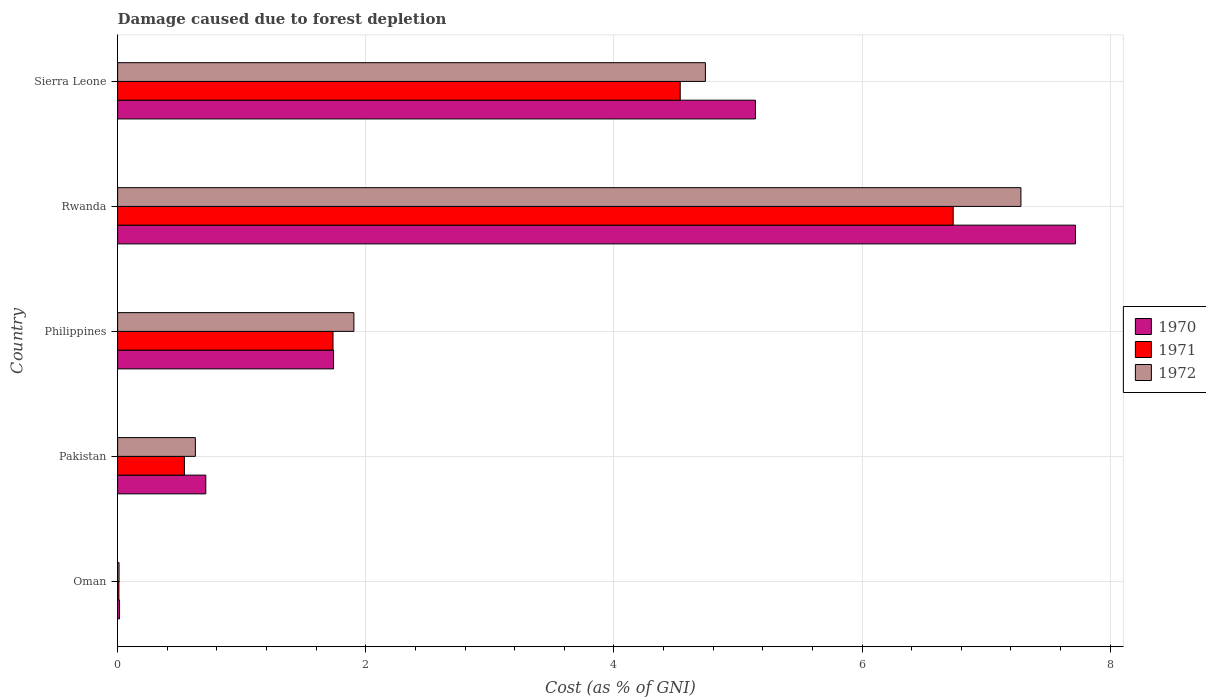How many different coloured bars are there?
Your response must be concise. 3. How many groups of bars are there?
Ensure brevity in your answer.  5. Are the number of bars per tick equal to the number of legend labels?
Offer a very short reply. Yes. What is the label of the 2nd group of bars from the top?
Ensure brevity in your answer.  Rwanda. In how many cases, is the number of bars for a given country not equal to the number of legend labels?
Make the answer very short. 0. What is the cost of damage caused due to forest depletion in 1972 in Rwanda?
Ensure brevity in your answer.  7.28. Across all countries, what is the maximum cost of damage caused due to forest depletion in 1970?
Your answer should be compact. 7.72. Across all countries, what is the minimum cost of damage caused due to forest depletion in 1972?
Give a very brief answer. 0.01. In which country was the cost of damage caused due to forest depletion in 1970 maximum?
Keep it short and to the point. Rwanda. In which country was the cost of damage caused due to forest depletion in 1972 minimum?
Provide a succinct answer. Oman. What is the total cost of damage caused due to forest depletion in 1972 in the graph?
Offer a terse response. 14.56. What is the difference between the cost of damage caused due to forest depletion in 1972 in Oman and that in Pakistan?
Offer a very short reply. -0.62. What is the difference between the cost of damage caused due to forest depletion in 1970 in Philippines and the cost of damage caused due to forest depletion in 1972 in Oman?
Provide a succinct answer. 1.73. What is the average cost of damage caused due to forest depletion in 1970 per country?
Your response must be concise. 3.07. What is the difference between the cost of damage caused due to forest depletion in 1972 and cost of damage caused due to forest depletion in 1971 in Sierra Leone?
Provide a succinct answer. 0.2. What is the ratio of the cost of damage caused due to forest depletion in 1971 in Pakistan to that in Philippines?
Ensure brevity in your answer.  0.31. Is the difference between the cost of damage caused due to forest depletion in 1972 in Pakistan and Sierra Leone greater than the difference between the cost of damage caused due to forest depletion in 1971 in Pakistan and Sierra Leone?
Provide a short and direct response. No. What is the difference between the highest and the second highest cost of damage caused due to forest depletion in 1970?
Make the answer very short. 2.58. What is the difference between the highest and the lowest cost of damage caused due to forest depletion in 1971?
Provide a short and direct response. 6.72. In how many countries, is the cost of damage caused due to forest depletion in 1970 greater than the average cost of damage caused due to forest depletion in 1970 taken over all countries?
Your answer should be compact. 2. What does the 1st bar from the top in Philippines represents?
Keep it short and to the point. 1972. What does the 1st bar from the bottom in Rwanda represents?
Your answer should be compact. 1970. Are all the bars in the graph horizontal?
Your response must be concise. Yes. What is the difference between two consecutive major ticks on the X-axis?
Keep it short and to the point. 2. Does the graph contain any zero values?
Your response must be concise. No. How many legend labels are there?
Give a very brief answer. 3. How are the legend labels stacked?
Your response must be concise. Vertical. What is the title of the graph?
Provide a short and direct response. Damage caused due to forest depletion. What is the label or title of the X-axis?
Offer a terse response. Cost (as % of GNI). What is the Cost (as % of GNI) of 1970 in Oman?
Your answer should be very brief. 0.02. What is the Cost (as % of GNI) in 1971 in Oman?
Provide a succinct answer. 0.01. What is the Cost (as % of GNI) of 1972 in Oman?
Make the answer very short. 0.01. What is the Cost (as % of GNI) of 1970 in Pakistan?
Make the answer very short. 0.71. What is the Cost (as % of GNI) of 1971 in Pakistan?
Offer a terse response. 0.54. What is the Cost (as % of GNI) of 1972 in Pakistan?
Give a very brief answer. 0.63. What is the Cost (as % of GNI) of 1970 in Philippines?
Ensure brevity in your answer.  1.74. What is the Cost (as % of GNI) in 1971 in Philippines?
Offer a very short reply. 1.74. What is the Cost (as % of GNI) of 1972 in Philippines?
Your response must be concise. 1.9. What is the Cost (as % of GNI) in 1970 in Rwanda?
Your answer should be very brief. 7.72. What is the Cost (as % of GNI) of 1971 in Rwanda?
Give a very brief answer. 6.73. What is the Cost (as % of GNI) of 1972 in Rwanda?
Your answer should be compact. 7.28. What is the Cost (as % of GNI) of 1970 in Sierra Leone?
Offer a terse response. 5.14. What is the Cost (as % of GNI) in 1971 in Sierra Leone?
Keep it short and to the point. 4.53. What is the Cost (as % of GNI) in 1972 in Sierra Leone?
Offer a very short reply. 4.74. Across all countries, what is the maximum Cost (as % of GNI) of 1970?
Give a very brief answer. 7.72. Across all countries, what is the maximum Cost (as % of GNI) of 1971?
Ensure brevity in your answer.  6.73. Across all countries, what is the maximum Cost (as % of GNI) in 1972?
Your response must be concise. 7.28. Across all countries, what is the minimum Cost (as % of GNI) in 1970?
Your answer should be very brief. 0.02. Across all countries, what is the minimum Cost (as % of GNI) in 1971?
Your answer should be very brief. 0.01. Across all countries, what is the minimum Cost (as % of GNI) of 1972?
Make the answer very short. 0.01. What is the total Cost (as % of GNI) of 1970 in the graph?
Ensure brevity in your answer.  15.33. What is the total Cost (as % of GNI) in 1971 in the graph?
Your answer should be very brief. 13.55. What is the total Cost (as % of GNI) in 1972 in the graph?
Provide a succinct answer. 14.56. What is the difference between the Cost (as % of GNI) of 1970 in Oman and that in Pakistan?
Ensure brevity in your answer.  -0.7. What is the difference between the Cost (as % of GNI) in 1971 in Oman and that in Pakistan?
Your answer should be compact. -0.53. What is the difference between the Cost (as % of GNI) of 1972 in Oman and that in Pakistan?
Your answer should be compact. -0.62. What is the difference between the Cost (as % of GNI) of 1970 in Oman and that in Philippines?
Provide a succinct answer. -1.72. What is the difference between the Cost (as % of GNI) in 1971 in Oman and that in Philippines?
Offer a very short reply. -1.73. What is the difference between the Cost (as % of GNI) of 1972 in Oman and that in Philippines?
Make the answer very short. -1.89. What is the difference between the Cost (as % of GNI) in 1970 in Oman and that in Rwanda?
Make the answer very short. -7.7. What is the difference between the Cost (as % of GNI) of 1971 in Oman and that in Rwanda?
Give a very brief answer. -6.72. What is the difference between the Cost (as % of GNI) in 1972 in Oman and that in Rwanda?
Make the answer very short. -7.27. What is the difference between the Cost (as % of GNI) in 1970 in Oman and that in Sierra Leone?
Give a very brief answer. -5.13. What is the difference between the Cost (as % of GNI) in 1971 in Oman and that in Sierra Leone?
Offer a terse response. -4.52. What is the difference between the Cost (as % of GNI) of 1972 in Oman and that in Sierra Leone?
Offer a terse response. -4.73. What is the difference between the Cost (as % of GNI) of 1970 in Pakistan and that in Philippines?
Provide a succinct answer. -1.03. What is the difference between the Cost (as % of GNI) of 1971 in Pakistan and that in Philippines?
Keep it short and to the point. -1.2. What is the difference between the Cost (as % of GNI) of 1972 in Pakistan and that in Philippines?
Keep it short and to the point. -1.28. What is the difference between the Cost (as % of GNI) in 1970 in Pakistan and that in Rwanda?
Your answer should be very brief. -7.01. What is the difference between the Cost (as % of GNI) of 1971 in Pakistan and that in Rwanda?
Offer a terse response. -6.2. What is the difference between the Cost (as % of GNI) in 1972 in Pakistan and that in Rwanda?
Your answer should be very brief. -6.65. What is the difference between the Cost (as % of GNI) of 1970 in Pakistan and that in Sierra Leone?
Your response must be concise. -4.43. What is the difference between the Cost (as % of GNI) of 1971 in Pakistan and that in Sierra Leone?
Give a very brief answer. -4. What is the difference between the Cost (as % of GNI) of 1972 in Pakistan and that in Sierra Leone?
Offer a terse response. -4.11. What is the difference between the Cost (as % of GNI) in 1970 in Philippines and that in Rwanda?
Offer a very short reply. -5.98. What is the difference between the Cost (as % of GNI) in 1971 in Philippines and that in Rwanda?
Provide a short and direct response. -5. What is the difference between the Cost (as % of GNI) in 1972 in Philippines and that in Rwanda?
Give a very brief answer. -5.38. What is the difference between the Cost (as % of GNI) in 1970 in Philippines and that in Sierra Leone?
Your response must be concise. -3.4. What is the difference between the Cost (as % of GNI) of 1971 in Philippines and that in Sierra Leone?
Give a very brief answer. -2.8. What is the difference between the Cost (as % of GNI) of 1972 in Philippines and that in Sierra Leone?
Keep it short and to the point. -2.83. What is the difference between the Cost (as % of GNI) of 1970 in Rwanda and that in Sierra Leone?
Offer a terse response. 2.58. What is the difference between the Cost (as % of GNI) of 1971 in Rwanda and that in Sierra Leone?
Offer a very short reply. 2.2. What is the difference between the Cost (as % of GNI) in 1972 in Rwanda and that in Sierra Leone?
Ensure brevity in your answer.  2.54. What is the difference between the Cost (as % of GNI) in 1970 in Oman and the Cost (as % of GNI) in 1971 in Pakistan?
Give a very brief answer. -0.52. What is the difference between the Cost (as % of GNI) in 1970 in Oman and the Cost (as % of GNI) in 1972 in Pakistan?
Keep it short and to the point. -0.61. What is the difference between the Cost (as % of GNI) of 1971 in Oman and the Cost (as % of GNI) of 1972 in Pakistan?
Offer a terse response. -0.62. What is the difference between the Cost (as % of GNI) in 1970 in Oman and the Cost (as % of GNI) in 1971 in Philippines?
Offer a very short reply. -1.72. What is the difference between the Cost (as % of GNI) of 1970 in Oman and the Cost (as % of GNI) of 1972 in Philippines?
Provide a short and direct response. -1.89. What is the difference between the Cost (as % of GNI) of 1971 in Oman and the Cost (as % of GNI) of 1972 in Philippines?
Ensure brevity in your answer.  -1.89. What is the difference between the Cost (as % of GNI) of 1970 in Oman and the Cost (as % of GNI) of 1971 in Rwanda?
Provide a succinct answer. -6.72. What is the difference between the Cost (as % of GNI) of 1970 in Oman and the Cost (as % of GNI) of 1972 in Rwanda?
Provide a short and direct response. -7.26. What is the difference between the Cost (as % of GNI) in 1971 in Oman and the Cost (as % of GNI) in 1972 in Rwanda?
Offer a terse response. -7.27. What is the difference between the Cost (as % of GNI) of 1970 in Oman and the Cost (as % of GNI) of 1971 in Sierra Leone?
Your response must be concise. -4.52. What is the difference between the Cost (as % of GNI) of 1970 in Oman and the Cost (as % of GNI) of 1972 in Sierra Leone?
Keep it short and to the point. -4.72. What is the difference between the Cost (as % of GNI) of 1971 in Oman and the Cost (as % of GNI) of 1972 in Sierra Leone?
Offer a very short reply. -4.73. What is the difference between the Cost (as % of GNI) of 1970 in Pakistan and the Cost (as % of GNI) of 1971 in Philippines?
Give a very brief answer. -1.03. What is the difference between the Cost (as % of GNI) in 1970 in Pakistan and the Cost (as % of GNI) in 1972 in Philippines?
Your answer should be compact. -1.19. What is the difference between the Cost (as % of GNI) in 1971 in Pakistan and the Cost (as % of GNI) in 1972 in Philippines?
Your answer should be very brief. -1.37. What is the difference between the Cost (as % of GNI) in 1970 in Pakistan and the Cost (as % of GNI) in 1971 in Rwanda?
Offer a terse response. -6.02. What is the difference between the Cost (as % of GNI) in 1970 in Pakistan and the Cost (as % of GNI) in 1972 in Rwanda?
Keep it short and to the point. -6.57. What is the difference between the Cost (as % of GNI) in 1971 in Pakistan and the Cost (as % of GNI) in 1972 in Rwanda?
Make the answer very short. -6.74. What is the difference between the Cost (as % of GNI) in 1970 in Pakistan and the Cost (as % of GNI) in 1971 in Sierra Leone?
Give a very brief answer. -3.82. What is the difference between the Cost (as % of GNI) of 1970 in Pakistan and the Cost (as % of GNI) of 1972 in Sierra Leone?
Your response must be concise. -4.03. What is the difference between the Cost (as % of GNI) in 1971 in Pakistan and the Cost (as % of GNI) in 1972 in Sierra Leone?
Ensure brevity in your answer.  -4.2. What is the difference between the Cost (as % of GNI) of 1970 in Philippines and the Cost (as % of GNI) of 1971 in Rwanda?
Offer a very short reply. -4.99. What is the difference between the Cost (as % of GNI) in 1970 in Philippines and the Cost (as % of GNI) in 1972 in Rwanda?
Provide a short and direct response. -5.54. What is the difference between the Cost (as % of GNI) of 1971 in Philippines and the Cost (as % of GNI) of 1972 in Rwanda?
Ensure brevity in your answer.  -5.54. What is the difference between the Cost (as % of GNI) in 1970 in Philippines and the Cost (as % of GNI) in 1971 in Sierra Leone?
Make the answer very short. -2.79. What is the difference between the Cost (as % of GNI) of 1970 in Philippines and the Cost (as % of GNI) of 1972 in Sierra Leone?
Your answer should be compact. -3. What is the difference between the Cost (as % of GNI) in 1971 in Philippines and the Cost (as % of GNI) in 1972 in Sierra Leone?
Provide a short and direct response. -3. What is the difference between the Cost (as % of GNI) of 1970 in Rwanda and the Cost (as % of GNI) of 1971 in Sierra Leone?
Your answer should be very brief. 3.19. What is the difference between the Cost (as % of GNI) of 1970 in Rwanda and the Cost (as % of GNI) of 1972 in Sierra Leone?
Offer a very short reply. 2.98. What is the difference between the Cost (as % of GNI) in 1971 in Rwanda and the Cost (as % of GNI) in 1972 in Sierra Leone?
Offer a very short reply. 2. What is the average Cost (as % of GNI) of 1970 per country?
Provide a short and direct response. 3.07. What is the average Cost (as % of GNI) of 1971 per country?
Provide a short and direct response. 2.71. What is the average Cost (as % of GNI) in 1972 per country?
Keep it short and to the point. 2.91. What is the difference between the Cost (as % of GNI) of 1970 and Cost (as % of GNI) of 1971 in Oman?
Give a very brief answer. 0.01. What is the difference between the Cost (as % of GNI) of 1970 and Cost (as % of GNI) of 1972 in Oman?
Your response must be concise. 0. What is the difference between the Cost (as % of GNI) in 1971 and Cost (as % of GNI) in 1972 in Oman?
Your answer should be very brief. -0. What is the difference between the Cost (as % of GNI) in 1970 and Cost (as % of GNI) in 1971 in Pakistan?
Make the answer very short. 0.17. What is the difference between the Cost (as % of GNI) in 1970 and Cost (as % of GNI) in 1972 in Pakistan?
Your answer should be compact. 0.08. What is the difference between the Cost (as % of GNI) of 1971 and Cost (as % of GNI) of 1972 in Pakistan?
Your answer should be very brief. -0.09. What is the difference between the Cost (as % of GNI) of 1970 and Cost (as % of GNI) of 1971 in Philippines?
Your answer should be very brief. 0. What is the difference between the Cost (as % of GNI) of 1970 and Cost (as % of GNI) of 1972 in Philippines?
Offer a very short reply. -0.16. What is the difference between the Cost (as % of GNI) in 1971 and Cost (as % of GNI) in 1972 in Philippines?
Offer a very short reply. -0.17. What is the difference between the Cost (as % of GNI) in 1970 and Cost (as % of GNI) in 1971 in Rwanda?
Your answer should be compact. 0.99. What is the difference between the Cost (as % of GNI) in 1970 and Cost (as % of GNI) in 1972 in Rwanda?
Your response must be concise. 0.44. What is the difference between the Cost (as % of GNI) of 1971 and Cost (as % of GNI) of 1972 in Rwanda?
Your answer should be compact. -0.55. What is the difference between the Cost (as % of GNI) of 1970 and Cost (as % of GNI) of 1971 in Sierra Leone?
Provide a succinct answer. 0.61. What is the difference between the Cost (as % of GNI) of 1970 and Cost (as % of GNI) of 1972 in Sierra Leone?
Keep it short and to the point. 0.4. What is the difference between the Cost (as % of GNI) of 1971 and Cost (as % of GNI) of 1972 in Sierra Leone?
Keep it short and to the point. -0.2. What is the ratio of the Cost (as % of GNI) in 1970 in Oman to that in Pakistan?
Provide a succinct answer. 0.02. What is the ratio of the Cost (as % of GNI) of 1971 in Oman to that in Pakistan?
Your response must be concise. 0.02. What is the ratio of the Cost (as % of GNI) in 1972 in Oman to that in Pakistan?
Make the answer very short. 0.02. What is the ratio of the Cost (as % of GNI) in 1970 in Oman to that in Philippines?
Make the answer very short. 0.01. What is the ratio of the Cost (as % of GNI) in 1971 in Oman to that in Philippines?
Ensure brevity in your answer.  0.01. What is the ratio of the Cost (as % of GNI) in 1972 in Oman to that in Philippines?
Ensure brevity in your answer.  0.01. What is the ratio of the Cost (as % of GNI) in 1970 in Oman to that in Rwanda?
Your response must be concise. 0. What is the ratio of the Cost (as % of GNI) in 1971 in Oman to that in Rwanda?
Provide a succinct answer. 0. What is the ratio of the Cost (as % of GNI) of 1972 in Oman to that in Rwanda?
Ensure brevity in your answer.  0. What is the ratio of the Cost (as % of GNI) in 1970 in Oman to that in Sierra Leone?
Offer a very short reply. 0. What is the ratio of the Cost (as % of GNI) in 1971 in Oman to that in Sierra Leone?
Your response must be concise. 0. What is the ratio of the Cost (as % of GNI) of 1972 in Oman to that in Sierra Leone?
Provide a short and direct response. 0. What is the ratio of the Cost (as % of GNI) in 1970 in Pakistan to that in Philippines?
Offer a terse response. 0.41. What is the ratio of the Cost (as % of GNI) in 1971 in Pakistan to that in Philippines?
Ensure brevity in your answer.  0.31. What is the ratio of the Cost (as % of GNI) in 1972 in Pakistan to that in Philippines?
Provide a succinct answer. 0.33. What is the ratio of the Cost (as % of GNI) of 1970 in Pakistan to that in Rwanda?
Offer a very short reply. 0.09. What is the ratio of the Cost (as % of GNI) of 1971 in Pakistan to that in Rwanda?
Offer a terse response. 0.08. What is the ratio of the Cost (as % of GNI) in 1972 in Pakistan to that in Rwanda?
Give a very brief answer. 0.09. What is the ratio of the Cost (as % of GNI) in 1970 in Pakistan to that in Sierra Leone?
Keep it short and to the point. 0.14. What is the ratio of the Cost (as % of GNI) in 1971 in Pakistan to that in Sierra Leone?
Your answer should be compact. 0.12. What is the ratio of the Cost (as % of GNI) of 1972 in Pakistan to that in Sierra Leone?
Your answer should be very brief. 0.13. What is the ratio of the Cost (as % of GNI) in 1970 in Philippines to that in Rwanda?
Your answer should be compact. 0.23. What is the ratio of the Cost (as % of GNI) in 1971 in Philippines to that in Rwanda?
Make the answer very short. 0.26. What is the ratio of the Cost (as % of GNI) of 1972 in Philippines to that in Rwanda?
Your answer should be compact. 0.26. What is the ratio of the Cost (as % of GNI) in 1970 in Philippines to that in Sierra Leone?
Give a very brief answer. 0.34. What is the ratio of the Cost (as % of GNI) of 1971 in Philippines to that in Sierra Leone?
Give a very brief answer. 0.38. What is the ratio of the Cost (as % of GNI) of 1972 in Philippines to that in Sierra Leone?
Your answer should be compact. 0.4. What is the ratio of the Cost (as % of GNI) of 1970 in Rwanda to that in Sierra Leone?
Your answer should be very brief. 1.5. What is the ratio of the Cost (as % of GNI) of 1971 in Rwanda to that in Sierra Leone?
Provide a succinct answer. 1.49. What is the ratio of the Cost (as % of GNI) of 1972 in Rwanda to that in Sierra Leone?
Ensure brevity in your answer.  1.54. What is the difference between the highest and the second highest Cost (as % of GNI) in 1970?
Your response must be concise. 2.58. What is the difference between the highest and the second highest Cost (as % of GNI) of 1971?
Give a very brief answer. 2.2. What is the difference between the highest and the second highest Cost (as % of GNI) of 1972?
Give a very brief answer. 2.54. What is the difference between the highest and the lowest Cost (as % of GNI) in 1970?
Provide a succinct answer. 7.7. What is the difference between the highest and the lowest Cost (as % of GNI) of 1971?
Provide a succinct answer. 6.72. What is the difference between the highest and the lowest Cost (as % of GNI) in 1972?
Your answer should be compact. 7.27. 